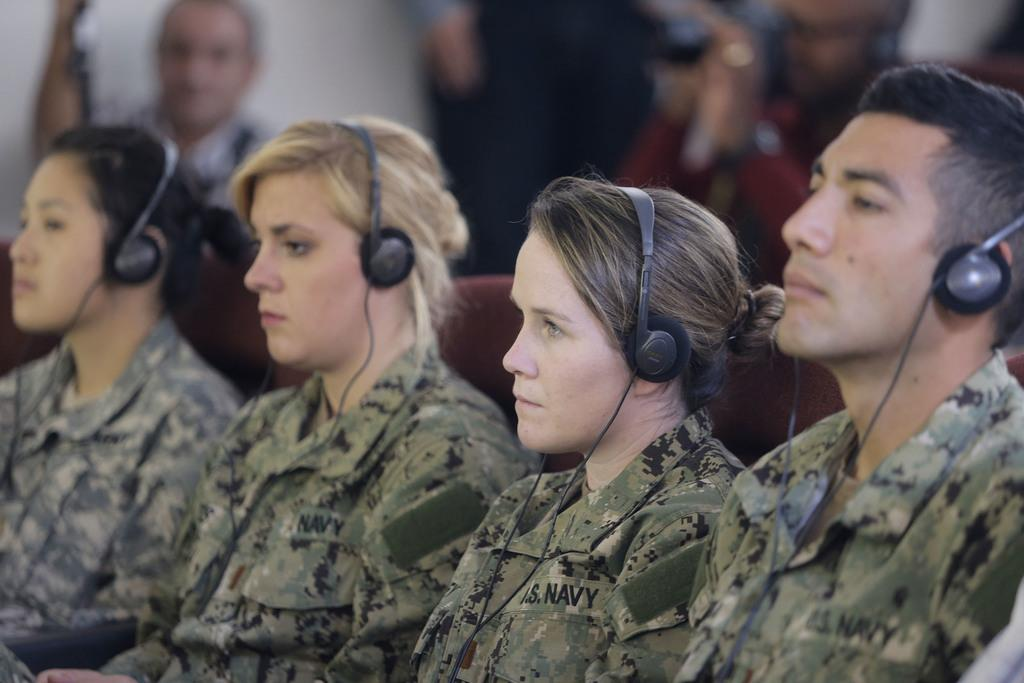How many people are in the image? There are four people in the image: three women and one man. What are the individuals wearing in the image? All the individuals are wearing headphones and uniforms. What are the individuals doing in the image? The individuals are sitting. Can you describe the background of the image? The background of the image is blurred. Is there anyone else visible in the image besides the four individuals? Yes, there is a person visible in the background of the image. What story is the fifth person telling in the image? There is no fifth person present in the image, and therefore no story can be told. 